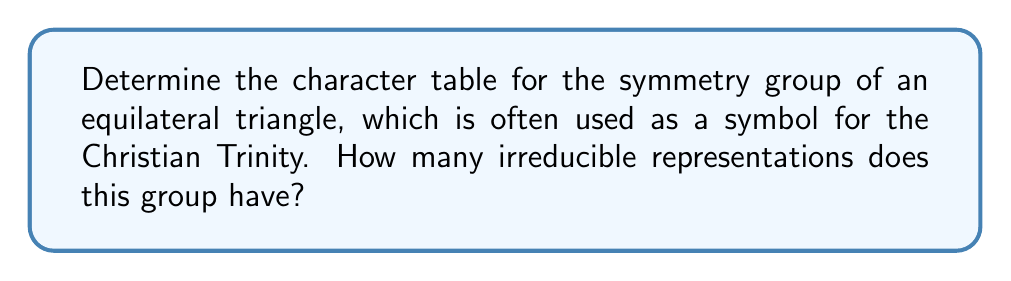Can you solve this math problem? 1. Identify the symmetry group: The symmetry group of an equilateral triangle is $D_3$ (dihedral group of order 6).

2. List the elements of $D_3$:
   - Identity (e)
   - Two 120° rotations ($r$, $r^2$)
   - Three reflections ($s$, $sr$, $sr^2$)

3. Determine the conjugacy classes:
   - $\{e\}$
   - $\{r, r^2\}$
   - $\{s, sr, sr^2\}$

4. The number of irreducible representations equals the number of conjugacy classes, which is 3.

5. Construct the character table:

   $$\begin{array}{c|ccc}
    D_3 & \{e\} & \{r, r^2\} & \{s, sr, sr^2\} \\
   \hline
   \chi_1 & 1 & 1 & 1 \\
   \chi_2 & 1 & 1 & -1 \\
   \chi_3 & 2 & -1 & 0
   \end{array}$$

   - $\chi_1$ is the trivial representation
   - $\chi_2$ is the sign representation
   - $\chi_3$ is the 2-dimensional irreducible representation

6. Verify the orthogonality relations and that $\sum_i (\dim \chi_i)^2 = |G| = 6$
Answer: 3 irreducible representations 